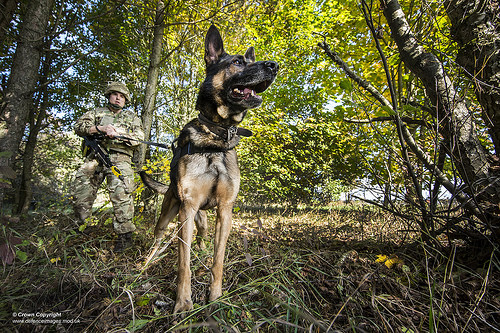<image>
Can you confirm if the dog is in the man? No. The dog is not contained within the man. These objects have a different spatial relationship. 